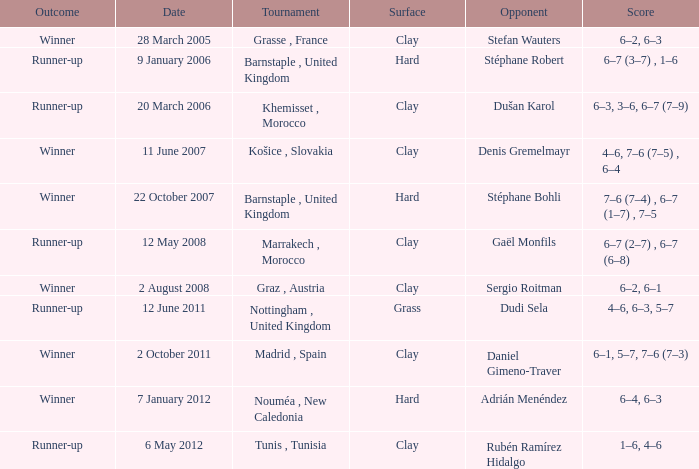On which surface was the competition held, where there was a second-place finish and dudi sela as the opponent? Grass. 